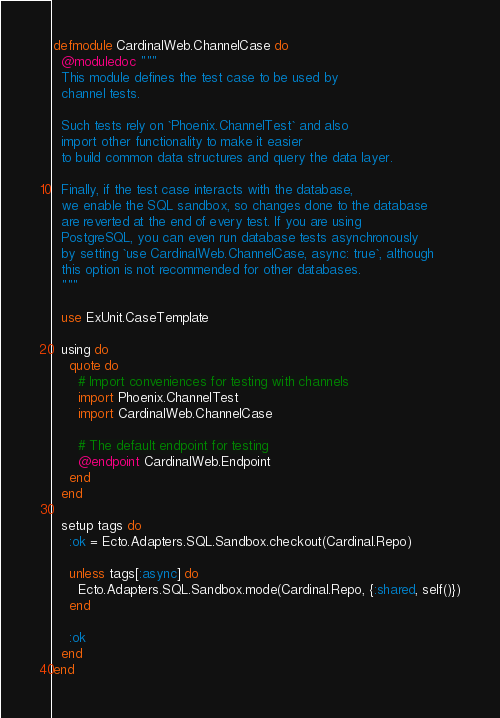Convert code to text. <code><loc_0><loc_0><loc_500><loc_500><_Elixir_>defmodule CardinalWeb.ChannelCase do
  @moduledoc """
  This module defines the test case to be used by
  channel tests.

  Such tests rely on `Phoenix.ChannelTest` and also
  import other functionality to make it easier
  to build common data structures and query the data layer.

  Finally, if the test case interacts with the database,
  we enable the SQL sandbox, so changes done to the database
  are reverted at the end of every test. If you are using
  PostgreSQL, you can even run database tests asynchronously
  by setting `use CardinalWeb.ChannelCase, async: true`, although
  this option is not recommended for other databases.
  """

  use ExUnit.CaseTemplate

  using do
    quote do
      # Import conveniences for testing with channels
      import Phoenix.ChannelTest
      import CardinalWeb.ChannelCase

      # The default endpoint for testing
      @endpoint CardinalWeb.Endpoint
    end
  end

  setup tags do
    :ok = Ecto.Adapters.SQL.Sandbox.checkout(Cardinal.Repo)

    unless tags[:async] do
      Ecto.Adapters.SQL.Sandbox.mode(Cardinal.Repo, {:shared, self()})
    end

    :ok
  end
end
</code> 